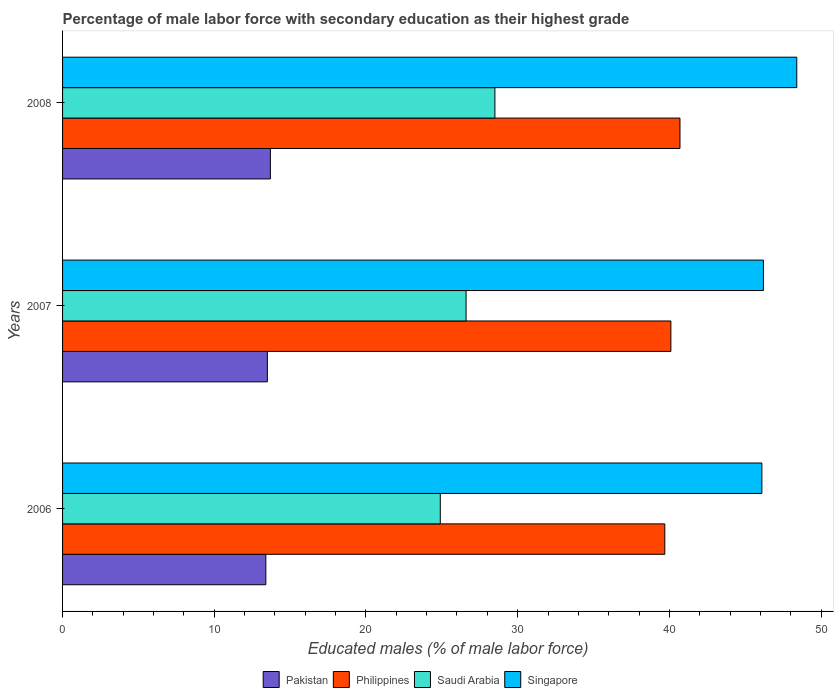How many groups of bars are there?
Your answer should be very brief. 3. What is the label of the 1st group of bars from the top?
Your answer should be compact. 2008. In how many cases, is the number of bars for a given year not equal to the number of legend labels?
Provide a short and direct response. 0. What is the percentage of male labor force with secondary education in Pakistan in 2006?
Provide a short and direct response. 13.4. Across all years, what is the maximum percentage of male labor force with secondary education in Singapore?
Offer a terse response. 48.4. Across all years, what is the minimum percentage of male labor force with secondary education in Philippines?
Your answer should be compact. 39.7. In which year was the percentage of male labor force with secondary education in Singapore maximum?
Your answer should be very brief. 2008. What is the total percentage of male labor force with secondary education in Singapore in the graph?
Keep it short and to the point. 140.7. What is the difference between the percentage of male labor force with secondary education in Philippines in 2006 and that in 2008?
Keep it short and to the point. -1. What is the difference between the percentage of male labor force with secondary education in Singapore in 2008 and the percentage of male labor force with secondary education in Saudi Arabia in 2007?
Offer a very short reply. 21.8. What is the average percentage of male labor force with secondary education in Singapore per year?
Your answer should be very brief. 46.9. In the year 2006, what is the difference between the percentage of male labor force with secondary education in Singapore and percentage of male labor force with secondary education in Pakistan?
Provide a succinct answer. 32.7. What is the ratio of the percentage of male labor force with secondary education in Saudi Arabia in 2007 to that in 2008?
Make the answer very short. 0.93. What is the difference between the highest and the second highest percentage of male labor force with secondary education in Singapore?
Offer a very short reply. 2.2. What is the difference between the highest and the lowest percentage of male labor force with secondary education in Pakistan?
Your answer should be compact. 0.3. Is it the case that in every year, the sum of the percentage of male labor force with secondary education in Saudi Arabia and percentage of male labor force with secondary education in Pakistan is greater than the sum of percentage of male labor force with secondary education in Philippines and percentage of male labor force with secondary education in Singapore?
Provide a succinct answer. Yes. Is it the case that in every year, the sum of the percentage of male labor force with secondary education in Saudi Arabia and percentage of male labor force with secondary education in Pakistan is greater than the percentage of male labor force with secondary education in Philippines?
Give a very brief answer. No. How many years are there in the graph?
Your answer should be compact. 3. Does the graph contain any zero values?
Give a very brief answer. No. Where does the legend appear in the graph?
Give a very brief answer. Bottom center. How many legend labels are there?
Make the answer very short. 4. How are the legend labels stacked?
Provide a short and direct response. Horizontal. What is the title of the graph?
Keep it short and to the point. Percentage of male labor force with secondary education as their highest grade. Does "Lower middle income" appear as one of the legend labels in the graph?
Ensure brevity in your answer.  No. What is the label or title of the X-axis?
Keep it short and to the point. Educated males (% of male labor force). What is the label or title of the Y-axis?
Make the answer very short. Years. What is the Educated males (% of male labor force) of Pakistan in 2006?
Make the answer very short. 13.4. What is the Educated males (% of male labor force) of Philippines in 2006?
Ensure brevity in your answer.  39.7. What is the Educated males (% of male labor force) of Saudi Arabia in 2006?
Give a very brief answer. 24.9. What is the Educated males (% of male labor force) of Singapore in 2006?
Offer a terse response. 46.1. What is the Educated males (% of male labor force) in Pakistan in 2007?
Make the answer very short. 13.5. What is the Educated males (% of male labor force) in Philippines in 2007?
Offer a terse response. 40.1. What is the Educated males (% of male labor force) of Saudi Arabia in 2007?
Offer a very short reply. 26.6. What is the Educated males (% of male labor force) of Singapore in 2007?
Your answer should be compact. 46.2. What is the Educated males (% of male labor force) in Pakistan in 2008?
Provide a short and direct response. 13.7. What is the Educated males (% of male labor force) of Philippines in 2008?
Ensure brevity in your answer.  40.7. What is the Educated males (% of male labor force) in Singapore in 2008?
Give a very brief answer. 48.4. Across all years, what is the maximum Educated males (% of male labor force) in Pakistan?
Provide a short and direct response. 13.7. Across all years, what is the maximum Educated males (% of male labor force) of Philippines?
Your answer should be very brief. 40.7. Across all years, what is the maximum Educated males (% of male labor force) of Saudi Arabia?
Your response must be concise. 28.5. Across all years, what is the maximum Educated males (% of male labor force) of Singapore?
Provide a succinct answer. 48.4. Across all years, what is the minimum Educated males (% of male labor force) of Pakistan?
Provide a short and direct response. 13.4. Across all years, what is the minimum Educated males (% of male labor force) of Philippines?
Provide a succinct answer. 39.7. Across all years, what is the minimum Educated males (% of male labor force) in Saudi Arabia?
Your answer should be very brief. 24.9. Across all years, what is the minimum Educated males (% of male labor force) in Singapore?
Give a very brief answer. 46.1. What is the total Educated males (% of male labor force) in Pakistan in the graph?
Provide a succinct answer. 40.6. What is the total Educated males (% of male labor force) of Philippines in the graph?
Provide a short and direct response. 120.5. What is the total Educated males (% of male labor force) in Singapore in the graph?
Your response must be concise. 140.7. What is the difference between the Educated males (% of male labor force) of Pakistan in 2006 and that in 2007?
Your response must be concise. -0.1. What is the difference between the Educated males (% of male labor force) in Singapore in 2006 and that in 2007?
Your answer should be very brief. -0.1. What is the difference between the Educated males (% of male labor force) of Philippines in 2006 and that in 2008?
Provide a succinct answer. -1. What is the difference between the Educated males (% of male labor force) of Saudi Arabia in 2006 and that in 2008?
Provide a succinct answer. -3.6. What is the difference between the Educated males (% of male labor force) of Philippines in 2007 and that in 2008?
Provide a succinct answer. -0.6. What is the difference between the Educated males (% of male labor force) of Pakistan in 2006 and the Educated males (% of male labor force) of Philippines in 2007?
Your response must be concise. -26.7. What is the difference between the Educated males (% of male labor force) of Pakistan in 2006 and the Educated males (% of male labor force) of Saudi Arabia in 2007?
Offer a very short reply. -13.2. What is the difference between the Educated males (% of male labor force) of Pakistan in 2006 and the Educated males (% of male labor force) of Singapore in 2007?
Make the answer very short. -32.8. What is the difference between the Educated males (% of male labor force) of Saudi Arabia in 2006 and the Educated males (% of male labor force) of Singapore in 2007?
Make the answer very short. -21.3. What is the difference between the Educated males (% of male labor force) in Pakistan in 2006 and the Educated males (% of male labor force) in Philippines in 2008?
Provide a short and direct response. -27.3. What is the difference between the Educated males (% of male labor force) of Pakistan in 2006 and the Educated males (% of male labor force) of Saudi Arabia in 2008?
Make the answer very short. -15.1. What is the difference between the Educated males (% of male labor force) of Pakistan in 2006 and the Educated males (% of male labor force) of Singapore in 2008?
Keep it short and to the point. -35. What is the difference between the Educated males (% of male labor force) of Philippines in 2006 and the Educated males (% of male labor force) of Saudi Arabia in 2008?
Give a very brief answer. 11.2. What is the difference between the Educated males (% of male labor force) of Philippines in 2006 and the Educated males (% of male labor force) of Singapore in 2008?
Make the answer very short. -8.7. What is the difference between the Educated males (% of male labor force) in Saudi Arabia in 2006 and the Educated males (% of male labor force) in Singapore in 2008?
Keep it short and to the point. -23.5. What is the difference between the Educated males (% of male labor force) in Pakistan in 2007 and the Educated males (% of male labor force) in Philippines in 2008?
Your answer should be compact. -27.2. What is the difference between the Educated males (% of male labor force) in Pakistan in 2007 and the Educated males (% of male labor force) in Saudi Arabia in 2008?
Your response must be concise. -15. What is the difference between the Educated males (% of male labor force) in Pakistan in 2007 and the Educated males (% of male labor force) in Singapore in 2008?
Your answer should be very brief. -34.9. What is the difference between the Educated males (% of male labor force) in Philippines in 2007 and the Educated males (% of male labor force) in Saudi Arabia in 2008?
Give a very brief answer. 11.6. What is the difference between the Educated males (% of male labor force) of Saudi Arabia in 2007 and the Educated males (% of male labor force) of Singapore in 2008?
Give a very brief answer. -21.8. What is the average Educated males (% of male labor force) of Pakistan per year?
Your answer should be compact. 13.53. What is the average Educated males (% of male labor force) of Philippines per year?
Your response must be concise. 40.17. What is the average Educated males (% of male labor force) of Saudi Arabia per year?
Your response must be concise. 26.67. What is the average Educated males (% of male labor force) in Singapore per year?
Provide a short and direct response. 46.9. In the year 2006, what is the difference between the Educated males (% of male labor force) of Pakistan and Educated males (% of male labor force) of Philippines?
Offer a terse response. -26.3. In the year 2006, what is the difference between the Educated males (% of male labor force) of Pakistan and Educated males (% of male labor force) of Singapore?
Make the answer very short. -32.7. In the year 2006, what is the difference between the Educated males (% of male labor force) of Philippines and Educated males (% of male labor force) of Singapore?
Give a very brief answer. -6.4. In the year 2006, what is the difference between the Educated males (% of male labor force) in Saudi Arabia and Educated males (% of male labor force) in Singapore?
Give a very brief answer. -21.2. In the year 2007, what is the difference between the Educated males (% of male labor force) in Pakistan and Educated males (% of male labor force) in Philippines?
Your response must be concise. -26.6. In the year 2007, what is the difference between the Educated males (% of male labor force) in Pakistan and Educated males (% of male labor force) in Singapore?
Provide a short and direct response. -32.7. In the year 2007, what is the difference between the Educated males (% of male labor force) in Philippines and Educated males (% of male labor force) in Singapore?
Give a very brief answer. -6.1. In the year 2007, what is the difference between the Educated males (% of male labor force) in Saudi Arabia and Educated males (% of male labor force) in Singapore?
Offer a terse response. -19.6. In the year 2008, what is the difference between the Educated males (% of male labor force) of Pakistan and Educated males (% of male labor force) of Saudi Arabia?
Make the answer very short. -14.8. In the year 2008, what is the difference between the Educated males (% of male labor force) in Pakistan and Educated males (% of male labor force) in Singapore?
Provide a succinct answer. -34.7. In the year 2008, what is the difference between the Educated males (% of male labor force) in Philippines and Educated males (% of male labor force) in Singapore?
Ensure brevity in your answer.  -7.7. In the year 2008, what is the difference between the Educated males (% of male labor force) of Saudi Arabia and Educated males (% of male labor force) of Singapore?
Provide a short and direct response. -19.9. What is the ratio of the Educated males (% of male labor force) in Philippines in 2006 to that in 2007?
Your answer should be very brief. 0.99. What is the ratio of the Educated males (% of male labor force) in Saudi Arabia in 2006 to that in 2007?
Ensure brevity in your answer.  0.94. What is the ratio of the Educated males (% of male labor force) of Pakistan in 2006 to that in 2008?
Make the answer very short. 0.98. What is the ratio of the Educated males (% of male labor force) of Philippines in 2006 to that in 2008?
Your response must be concise. 0.98. What is the ratio of the Educated males (% of male labor force) in Saudi Arabia in 2006 to that in 2008?
Make the answer very short. 0.87. What is the ratio of the Educated males (% of male labor force) of Singapore in 2006 to that in 2008?
Your answer should be very brief. 0.95. What is the ratio of the Educated males (% of male labor force) of Pakistan in 2007 to that in 2008?
Your response must be concise. 0.99. What is the ratio of the Educated males (% of male labor force) in Singapore in 2007 to that in 2008?
Ensure brevity in your answer.  0.95. What is the difference between the highest and the second highest Educated males (% of male labor force) in Philippines?
Your answer should be very brief. 0.6. What is the difference between the highest and the second highest Educated males (% of male labor force) in Singapore?
Offer a terse response. 2.2. What is the difference between the highest and the lowest Educated males (% of male labor force) in Pakistan?
Keep it short and to the point. 0.3. What is the difference between the highest and the lowest Educated males (% of male labor force) of Singapore?
Your answer should be very brief. 2.3. 